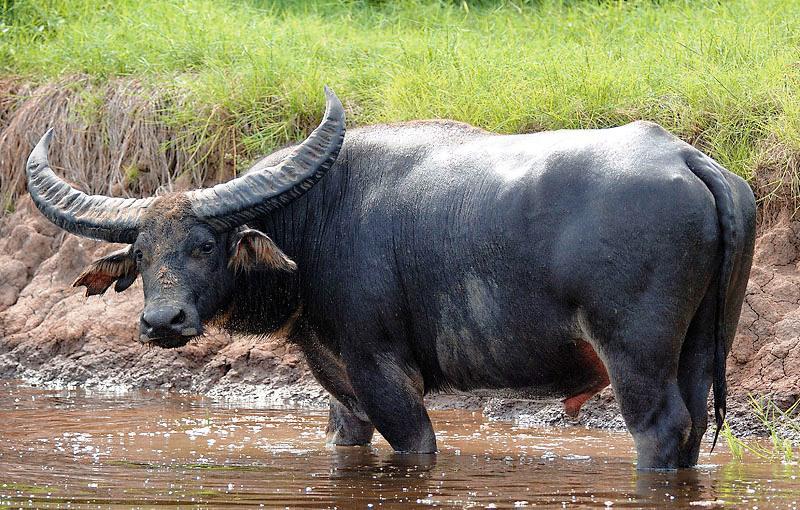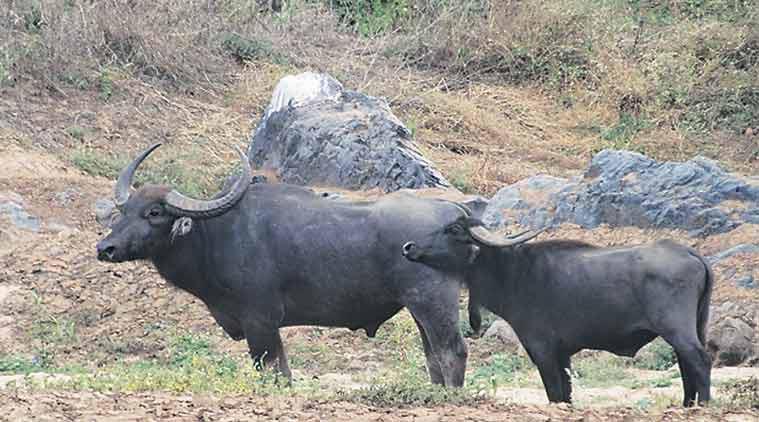The first image is the image on the left, the second image is the image on the right. For the images displayed, is the sentence "At least one water buffalo is standing in water." factually correct? Answer yes or no. Yes. The first image is the image on the left, the second image is the image on the right. Evaluate the accuracy of this statement regarding the images: "A water buffalo is walking through water in one image.". Is it true? Answer yes or no. Yes. The first image is the image on the left, the second image is the image on the right. Analyze the images presented: Is the assertion "A water buffalo happens to be in the water, in one of the images." valid? Answer yes or no. Yes. The first image is the image on the left, the second image is the image on the right. Given the left and right images, does the statement "Left image shows water buffalo upright in water." hold true? Answer yes or no. Yes. 